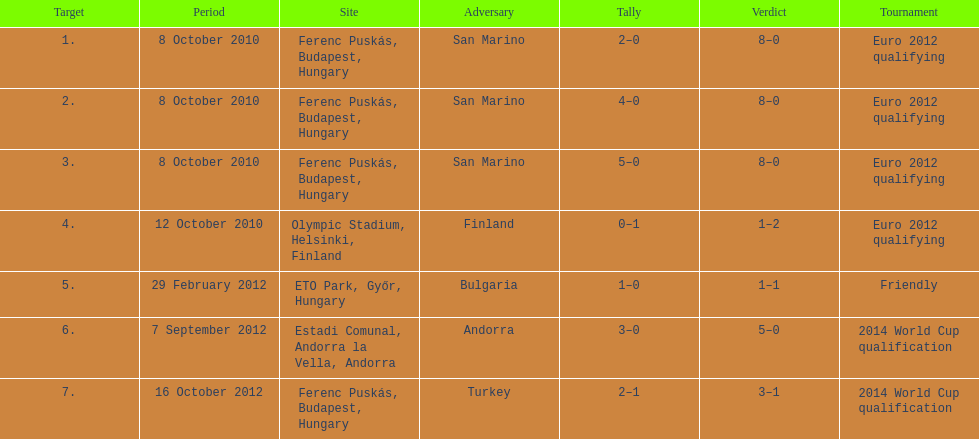Szalai scored only one more international goal against all other countries put together than he did against what one country? San Marino. 